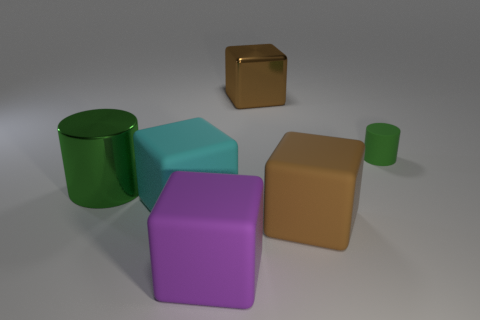Subtract all cyan cylinders. Subtract all blue blocks. How many cylinders are left? 2 Add 2 purple rubber cubes. How many objects exist? 8 Subtract all cylinders. How many objects are left? 4 Add 3 big green metal cylinders. How many big green metal cylinders are left? 4 Add 6 tiny cyan matte cubes. How many tiny cyan matte cubes exist? 6 Subtract 0 green cubes. How many objects are left? 6 Subtract all large green objects. Subtract all cyan things. How many objects are left? 4 